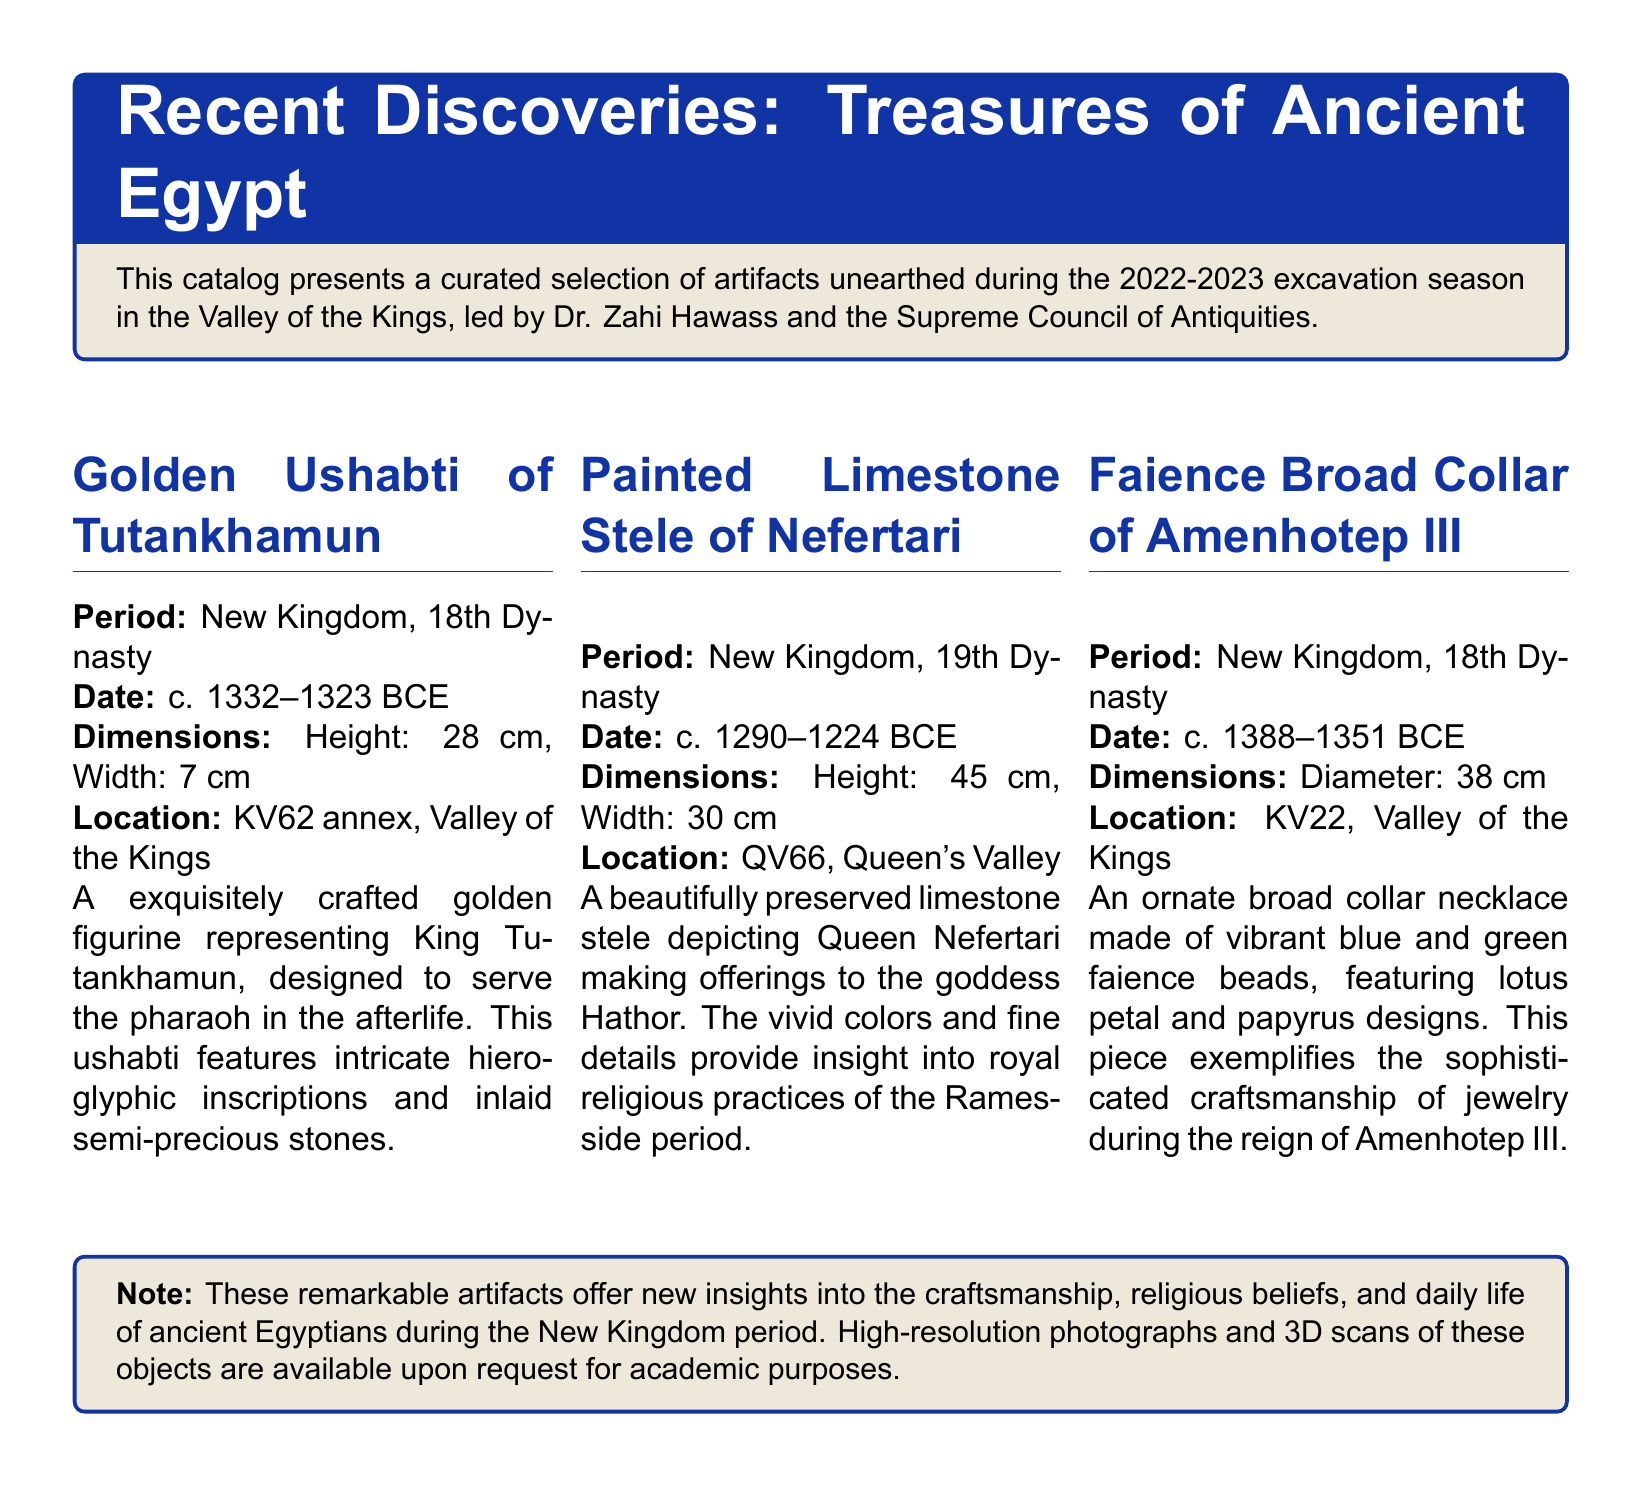what is the height of the Golden Ushabti of Tutankhamun? The height is specified in the document as a measurement of the artifact.
Answer: 28 cm what period does the Painted Limestone Stele of Nefertari belong to? The period is mentioned in the detailed description of the artifact.
Answer: New Kingdom, 19th Dynasty where was the Faience Broad Collar of Amenhotep III discovered? The location of discovery is clearly stated in the artifact details.
Answer: KV22, Valley of the Kings what is the primary material of the Golden Ushabti? The material is indicated in the artifact description.
Answer: Gold what years does the dating of the Painted Limestone Stele of Nefertari cover? The date range is specified in the document as part of the stele description.
Answer: c. 1290--1224 BCE which queen is depicted in the Limestone Stele? The document names the queen represented in the artifact.
Answer: Nefertari how many cm in diameter is the Faience Broad Collar? The diameter measurement is provided in the artifact's specifications.
Answer: 38 cm what notable feature does the Faience Broad Collar include? The description highlights specific design elements of the artifact.
Answer: Lotus petal and papyrus designs who led the excavation during the 2022-2023 season? The document states the name of the person responsible for the excavation project.
Answer: Dr. Zahi Hawass 